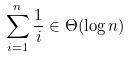<formula> <loc_0><loc_0><loc_500><loc_500>\sum _ { i = 1 } ^ { n } \frac { 1 } { i } \in \Theta ( \log n )</formula> 